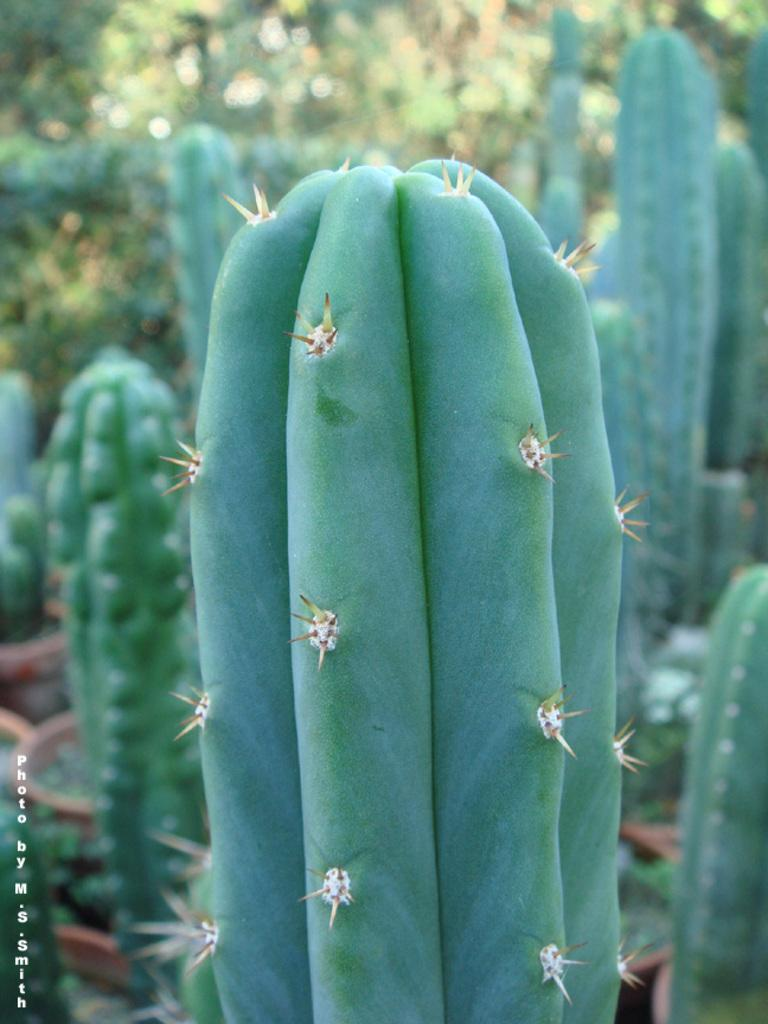What type of plants are in the image? There are cacti in the image. Where are the cacti located in the image? The cacti are in the middle of the image. What feature do the cacti have? The cacti have thorns. What type of pin can be seen holding a verse on the cactus in the image? There is no pin or verse present on the cactus in the image. What type of creature might have fangs that could be dangerous to the cactus in the image? There is no creature with fangs present in the image. 